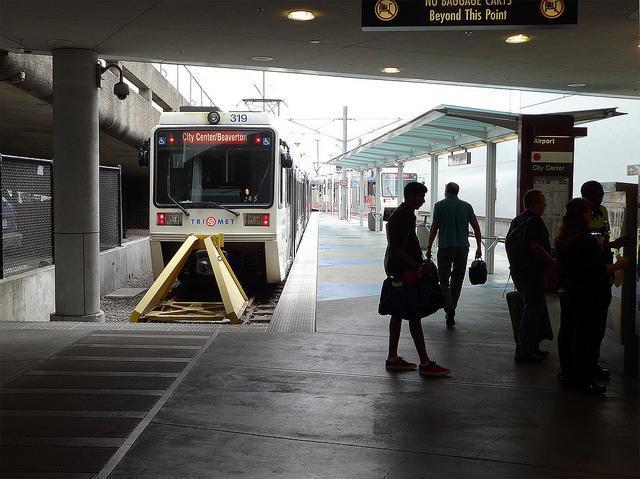How many lights are on the train?
Give a very brief answer. 4. How many trains can you see?
Give a very brief answer. 2. How many people are in the picture?
Give a very brief answer. 4. 